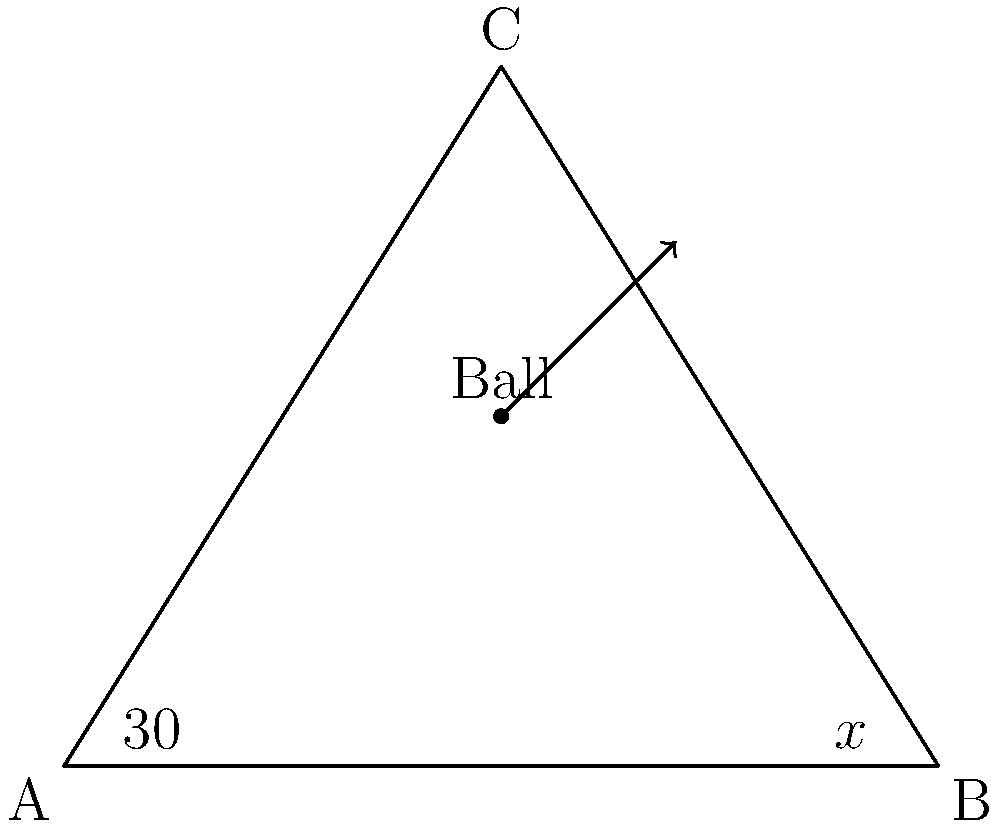In a game of pool, you're attempting a bank shot where the cue ball needs to hit the rail at point C and then the object ball at point B. If the angle between the rail (AB) and the line from A to C is 30°, what should be the angle x° between the rail and the line from B to C for the perfect bank shot? To solve this problem, we'll use the principle that the angle of incidence equals the angle of reflection in pool shots. Here's how we can approach it step-by-step:

1) In a triangle, the sum of all angles is 180°. Let's call the angle at C as y°.

   $$30° + y° + x° = 180°$$

2) For a perfect bank shot, the angle of incidence (30°) should equal the angle of reflection (x°).

   $$30° = x°$$

3) Substituting this into our equation from step 1:

   $$30° + y° + 30° = 180°$$

4) Simplifying:

   $$60° + y° = 180°$$

5) Solving for y°:

   $$y° = 180° - 60° = 120°$$

6) Therefore, the angle x° (which equals the angle of incidence) is:

   $$x° = 30°$$

This angle ensures that the cue ball will bounce off the rail at C and travel towards B, following the principle of equal angles of incidence and reflection.
Answer: $30°$ 